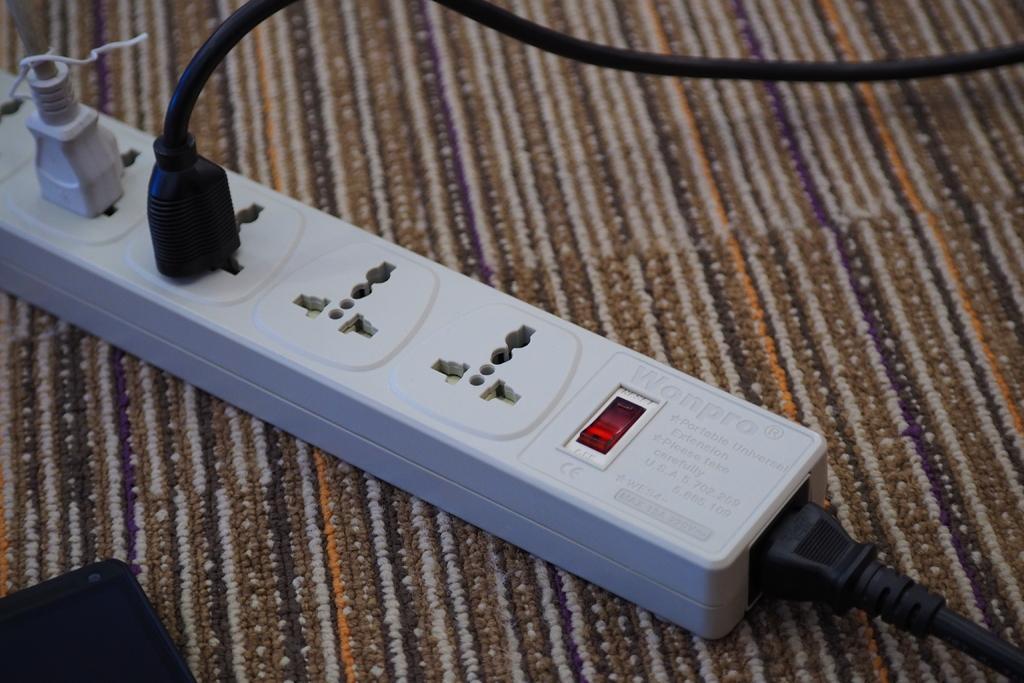Describe this image in one or two sentences. In this picture I can see the white color socket and two cables are connected. This socket is kept on the carpet. In the bottom left corner I can see the black object. 